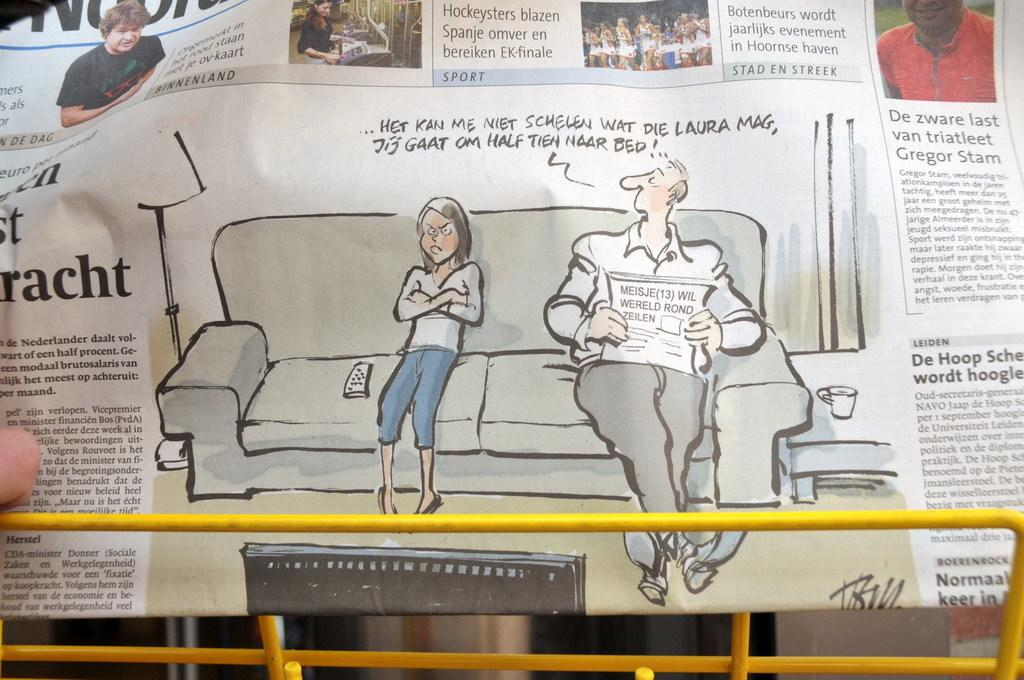What is the main object in the image? There is a newspaper in the image. What can be found within the newspaper? The newspaper contains text and images. Can you describe any human interaction with the newspaper? A person's finger is visible on the left side of the image. What type of object is at the bottom of the image? There is a metal object at the bottom of the image. What type of stitch is being used to hold the newspaper together? There is no stitch present in the image; the newspaper is not held together by any stitch. Can you see any branches in the image? There are no branches visible in the image. 